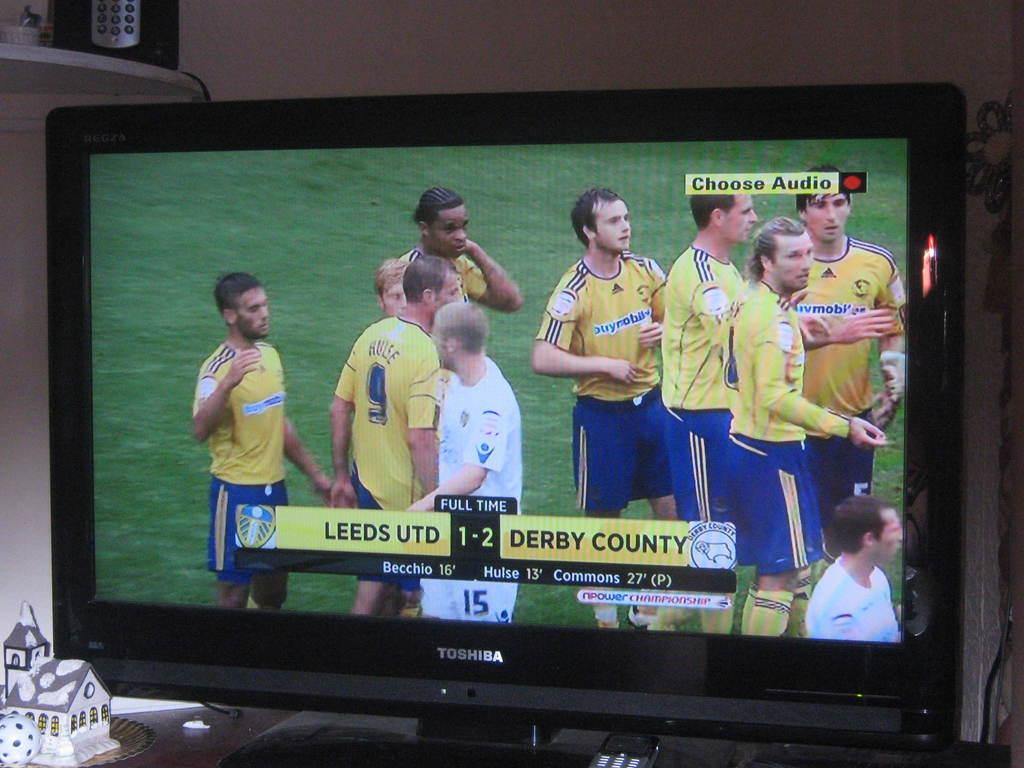<image>
Create a compact narrative representing the image presented. A black TV that says Toshiba is showing a soccer game and says Choose Audio in the top right. 